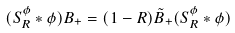Convert formula to latex. <formula><loc_0><loc_0><loc_500><loc_500>( S _ { R } ^ { \phi } \ast \phi ) B _ { + } = ( 1 - R ) \tilde { B } _ { + } ( S _ { R } ^ { \phi } \ast \phi )</formula> 